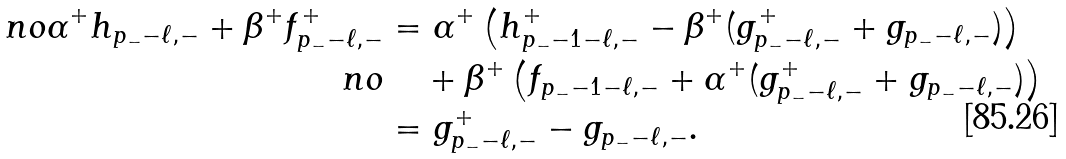<formula> <loc_0><loc_0><loc_500><loc_500>\ n o \alpha ^ { + } h _ { p _ { - } - \ell , - } + \beta ^ { + } f _ { p _ { - } - \ell , - } ^ { + } & = \alpha ^ { + } \left ( h _ { p _ { - } - 1 - \ell , - } ^ { + } - \beta ^ { + } ( g _ { p _ { - } - \ell , - } ^ { + } + g _ { p _ { - } - \ell , - } ) \right ) \\ \ n o & \quad + \beta ^ { + } \left ( f _ { p _ { - } - 1 - \ell , - } + \alpha ^ { + } ( g _ { p _ { - } - \ell , - } ^ { + } + g _ { p _ { - } - \ell , - } ) \right ) \\ & = g _ { p _ { - } - \ell , - } ^ { + } - g _ { p _ { - } - \ell , - } .</formula> 